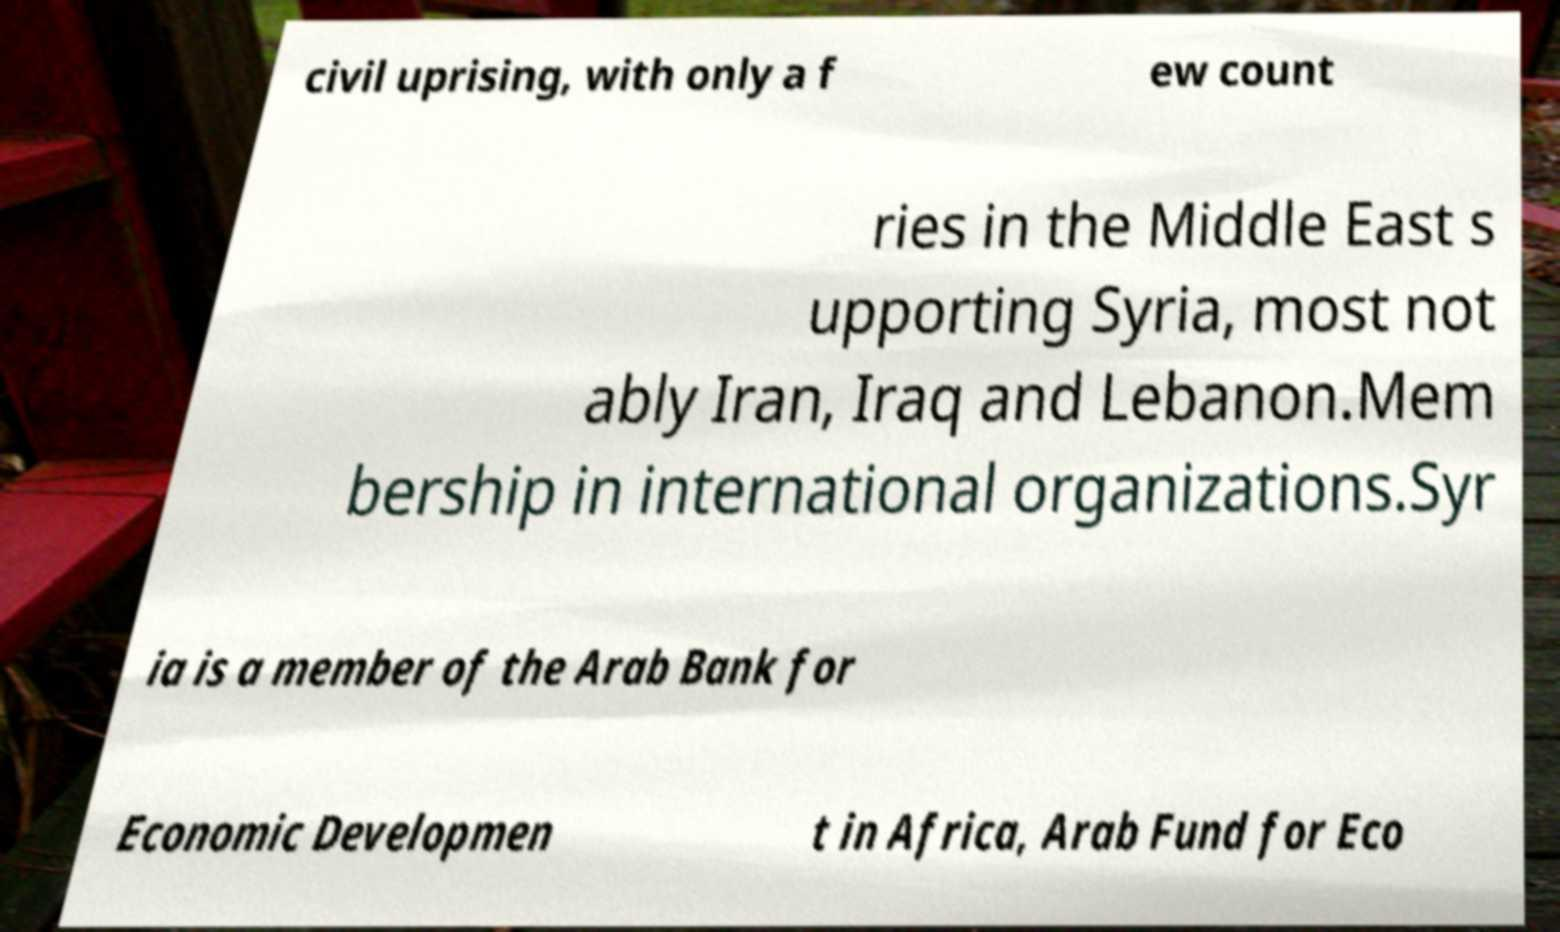For documentation purposes, I need the text within this image transcribed. Could you provide that? civil uprising, with only a f ew count ries in the Middle East s upporting Syria, most not ably Iran, Iraq and Lebanon.Mem bership in international organizations.Syr ia is a member of the Arab Bank for Economic Developmen t in Africa, Arab Fund for Eco 